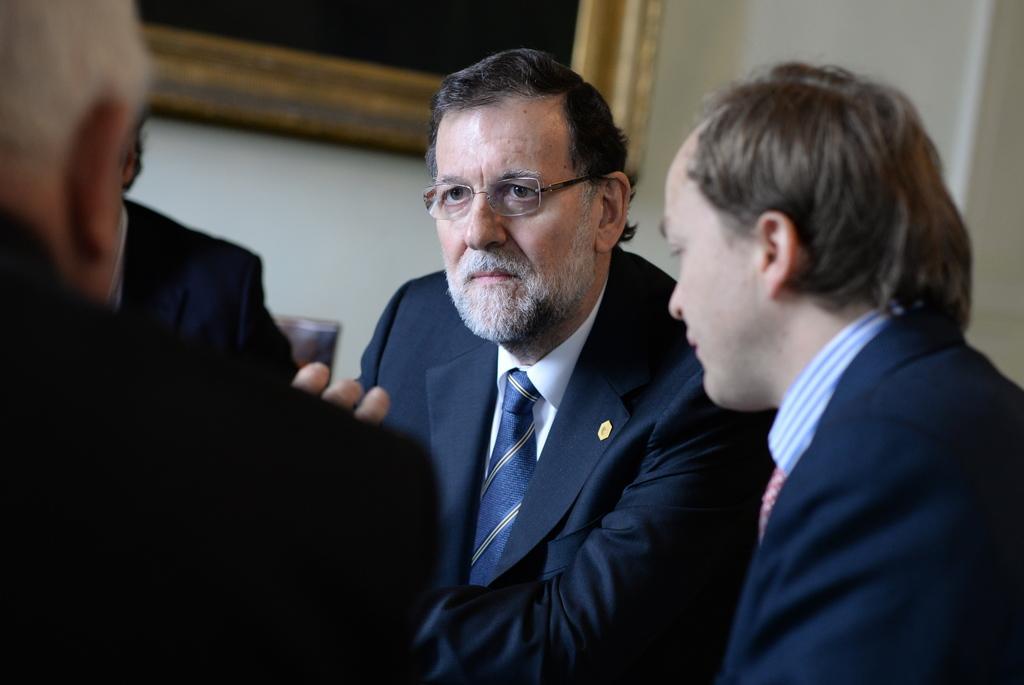How would you summarize this image in a sentence or two? On the right side, there are two persons in suits sitting. On the left side, there are two persons sitting. In the background, there is a photo frame on the white wall. 